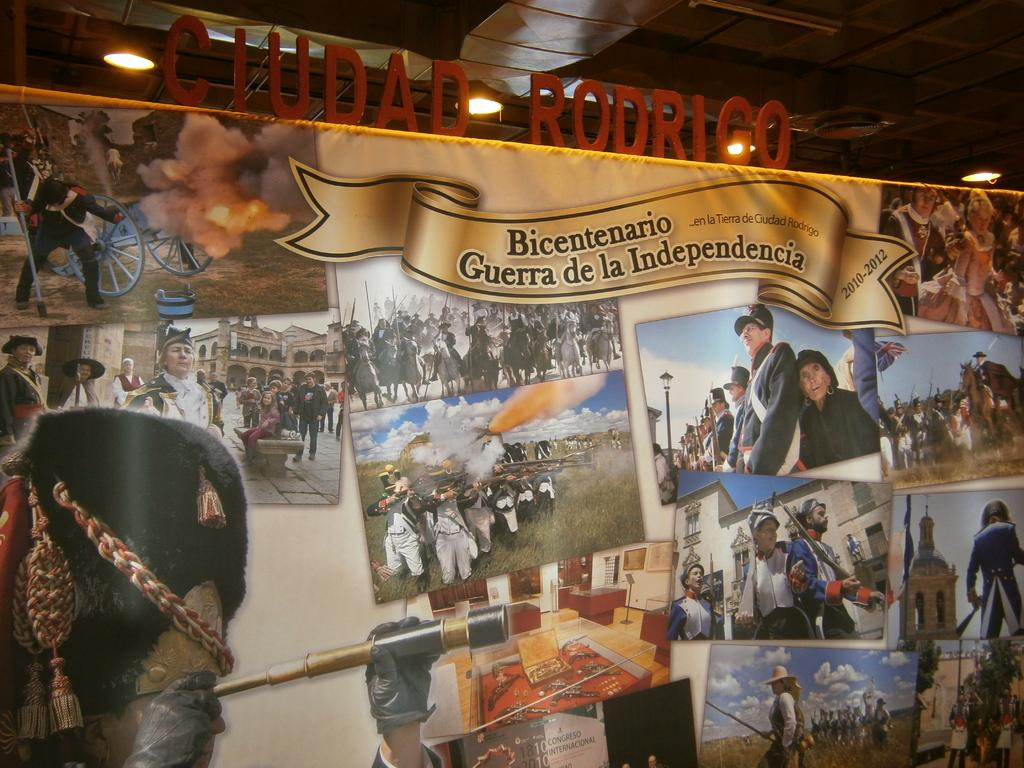What is hanging in the image? There is a banner in the image. What is depicted on the banner? The banner contains pictures. Who can be seen in the image? There are people in the image. What type of structures are visible in the image? There are buildings in the image. What type of natural environment is present in the image? There is grass in the image. What part of the natural environment is visible in the image? The sky is visible in the image. What else can be seen in the image besides the banner, people, buildings, grass, and sky? There are objects and lights in the image. What type of signage is present in the image? There are boards in the image. What type of record can be seen being produced in the image? There is no record being produced in the image; it does not contain any equipment or materials related to record production. What causes the lights to illuminate in the image? The cause of the lights illuminating in the image is not visible or mentioned in the image; it could be due to natural or artificial sources, but we cannot determine that from the image alone. 